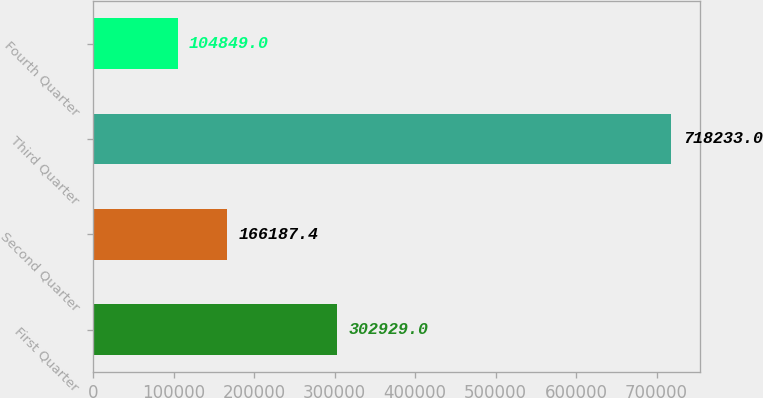Convert chart. <chart><loc_0><loc_0><loc_500><loc_500><bar_chart><fcel>First Quarter<fcel>Second Quarter<fcel>Third Quarter<fcel>Fourth Quarter<nl><fcel>302929<fcel>166187<fcel>718233<fcel>104849<nl></chart> 